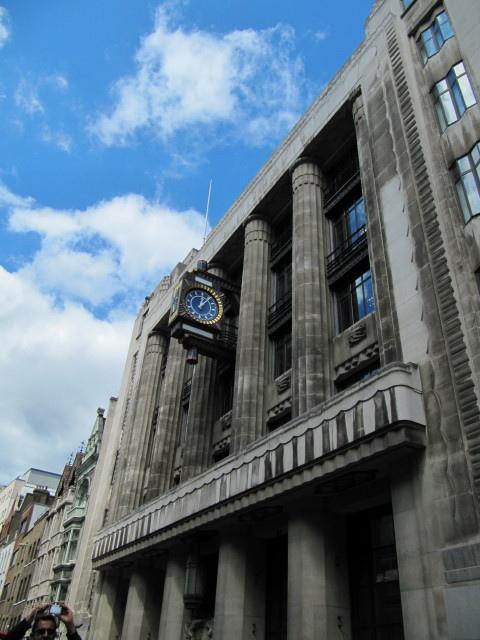How many walls are there?
Give a very brief answer. 1. 